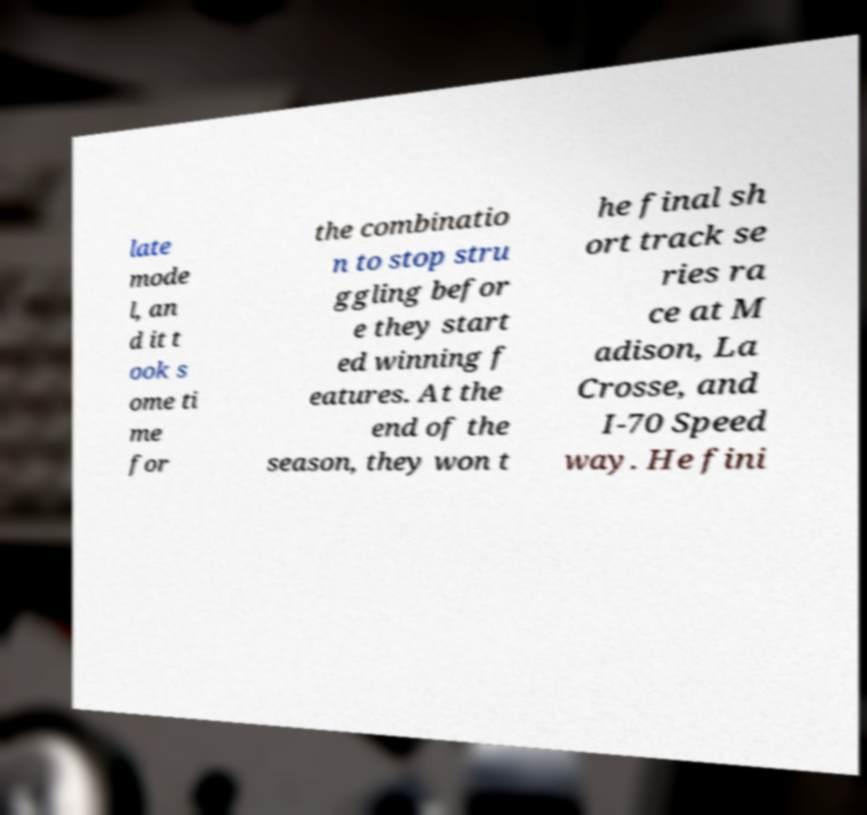For documentation purposes, I need the text within this image transcribed. Could you provide that? late mode l, an d it t ook s ome ti me for the combinatio n to stop stru ggling befor e they start ed winning f eatures. At the end of the season, they won t he final sh ort track se ries ra ce at M adison, La Crosse, and I-70 Speed way. He fini 